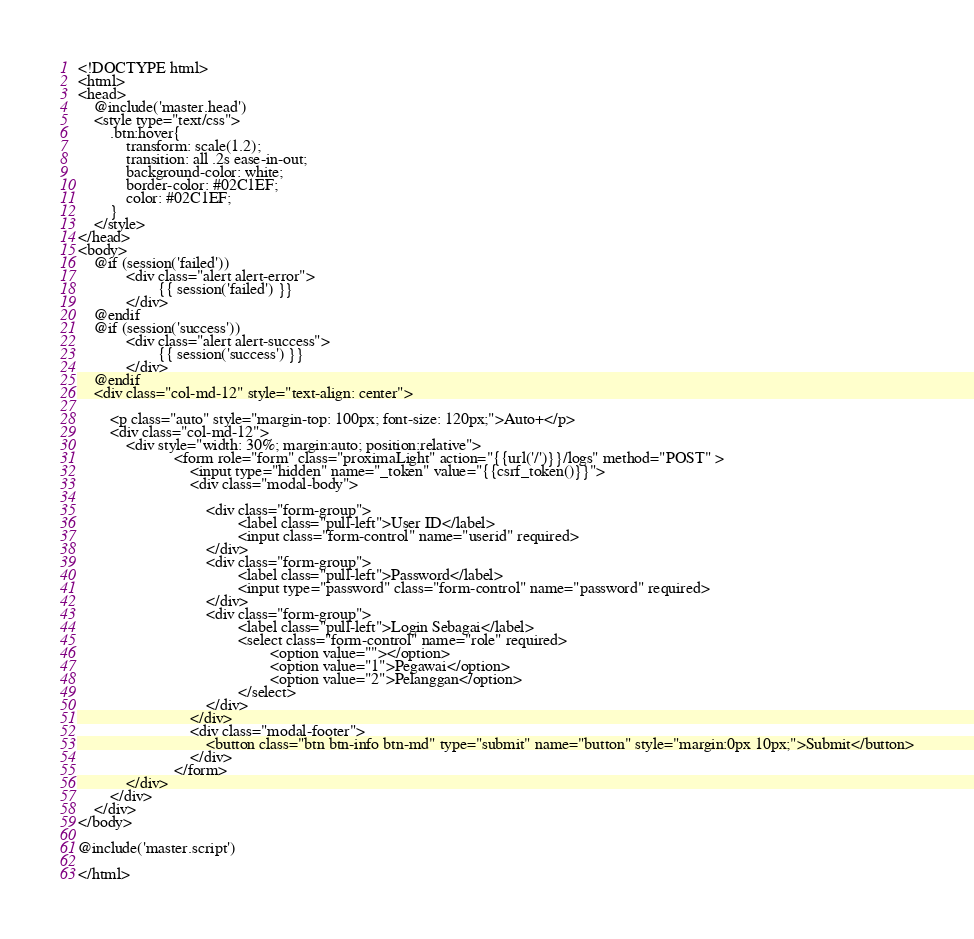<code> <loc_0><loc_0><loc_500><loc_500><_PHP_><!DOCTYPE html>
<html>
<head>
	@include('master.head')
	<style type="text/css">
		.btn:hover{
			transform: scale(1.2);
			transition: all .2s ease-in-out;
			background-color: white;
			border-color: #02C1EF;
			color: #02C1EF;
		}
	</style>
</head>
<body>
	@if (session('failed'))
			<div class="alert alert-error">
					{{ session('failed') }}
			</div>
	@endif
	@if (session('success'))
			<div class="alert alert-success">
					{{ session('success') }}
			</div>
	@endif
	<div class="col-md-12" style="text-align: center">

		<p class="auto" style="margin-top: 100px; font-size: 120px;">Auto+</p>
		<div class="col-md-12">
			<div style="width: 30%; margin:auto; position:relative">
						<form role="form" class="proximaLight" action="{{url('/')}}/logs" method="POST" >
							<input type="hidden" name="_token" value="{{csrf_token()}}">
							<div class="modal-body">

								<div class="form-group">
										<label class="pull-left">User ID</label>
										<input class="form-control" name="userid" required>
								</div>
								<div class="form-group">
										<label class="pull-left">Password</label>
										<input type="password" class="form-control" name="password" required>
								</div>
								<div class="form-group">
										<label class="pull-left">Login Sebagai</label>
										<select class="form-control" name="role" required>
												<option value=""></option>
												<option value="1">Pegawai</option>
												<option value="2">Pelanggan</option>
										</select>
								</div>
							</div>
							<div class="modal-footer">
								<button class="btn btn-info btn-md" type="submit" name="button" style="margin:0px 10px;">Submit</button>
							</div>
						</form>
			</div>
		</div>
	</div>
</body>

@include('master.script')

</html>
</code> 